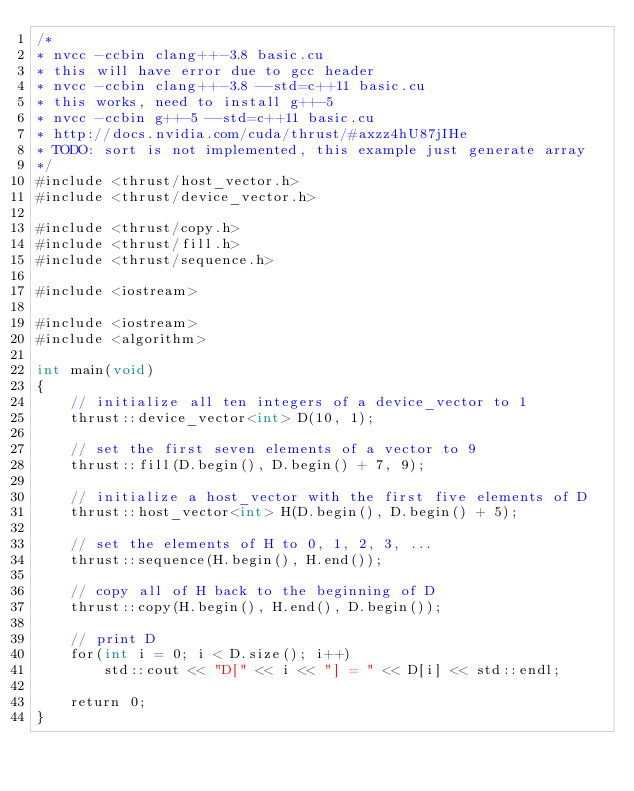<code> <loc_0><loc_0><loc_500><loc_500><_Cuda_>/*
* nvcc -ccbin clang++-3.8 basic.cu
* this will have error due to gcc header
* nvcc -ccbin clang++-3.8 --std=c++11 basic.cu
* this works, need to install g++-5
* nvcc -ccbin g++-5 --std=c++11 basic.cu
* http://docs.nvidia.com/cuda/thrust/#axzz4hU87jIHe
* TODO: sort is not implemented, this example just generate array
*/
#include <thrust/host_vector.h>
#include <thrust/device_vector.h>

#include <thrust/copy.h>
#include <thrust/fill.h>
#include <thrust/sequence.h>

#include <iostream>

#include <iostream>
#include <algorithm>

int main(void)
{
    // initialize all ten integers of a device_vector to 1
    thrust::device_vector<int> D(10, 1);

    // set the first seven elements of a vector to 9
    thrust::fill(D.begin(), D.begin() + 7, 9);

    // initialize a host_vector with the first five elements of D
    thrust::host_vector<int> H(D.begin(), D.begin() + 5);

    // set the elements of H to 0, 1, 2, 3, ...
    thrust::sequence(H.begin(), H.end());

    // copy all of H back to the beginning of D
    thrust::copy(H.begin(), H.end(), D.begin());

    // print D
    for(int i = 0; i < D.size(); i++)
        std::cout << "D[" << i << "] = " << D[i] << std::endl;

    return 0;
}
</code> 